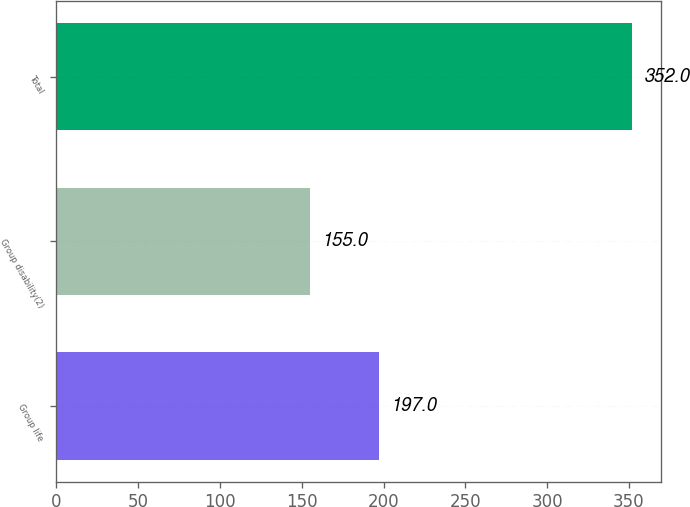Convert chart to OTSL. <chart><loc_0><loc_0><loc_500><loc_500><bar_chart><fcel>Group life<fcel>Group disability(2)<fcel>Total<nl><fcel>197<fcel>155<fcel>352<nl></chart> 